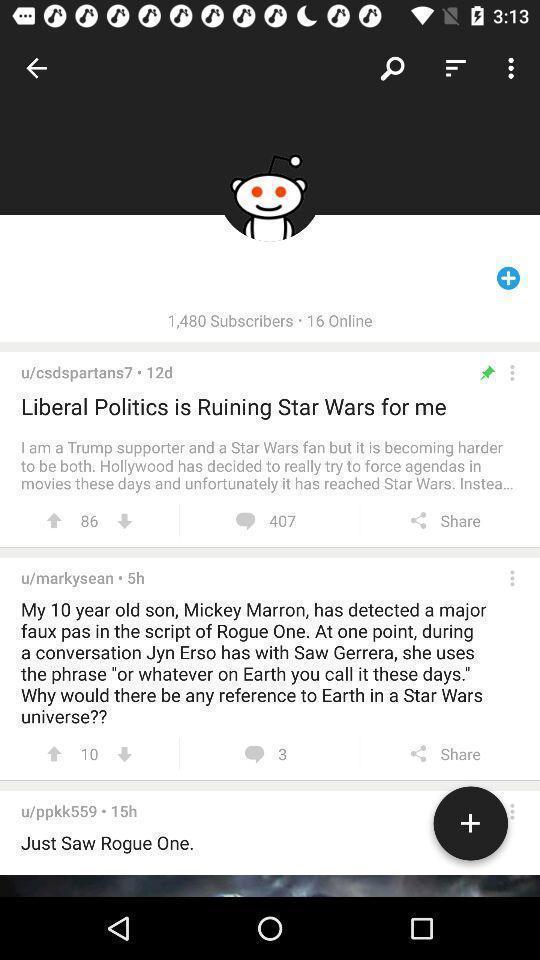What is the overall content of this screenshot? Screen showing various posts of a social app. 